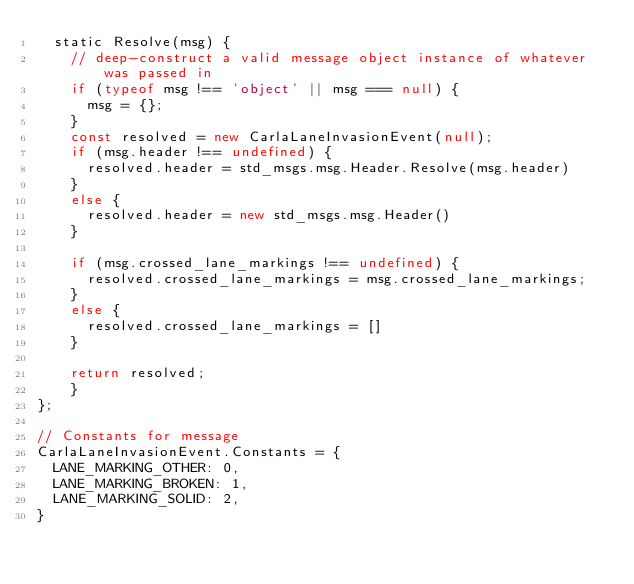Convert code to text. <code><loc_0><loc_0><loc_500><loc_500><_JavaScript_>  static Resolve(msg) {
    // deep-construct a valid message object instance of whatever was passed in
    if (typeof msg !== 'object' || msg === null) {
      msg = {};
    }
    const resolved = new CarlaLaneInvasionEvent(null);
    if (msg.header !== undefined) {
      resolved.header = std_msgs.msg.Header.Resolve(msg.header)
    }
    else {
      resolved.header = new std_msgs.msg.Header()
    }

    if (msg.crossed_lane_markings !== undefined) {
      resolved.crossed_lane_markings = msg.crossed_lane_markings;
    }
    else {
      resolved.crossed_lane_markings = []
    }

    return resolved;
    }
};

// Constants for message
CarlaLaneInvasionEvent.Constants = {
  LANE_MARKING_OTHER: 0,
  LANE_MARKING_BROKEN: 1,
  LANE_MARKING_SOLID: 2,
}
</code> 